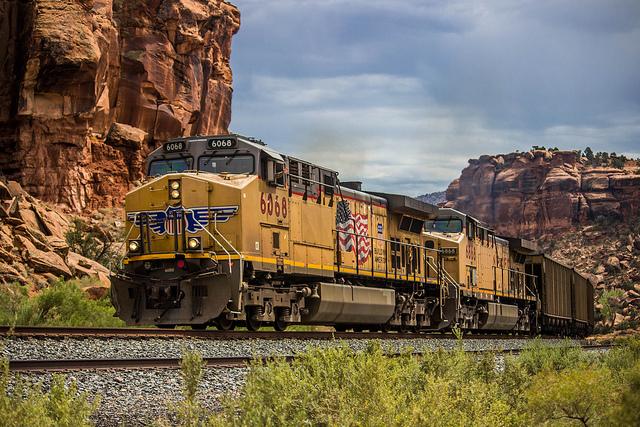Is the sun out?
Quick response, please. Yes. Is this train prepared for climbing terrain?
Be succinct. Yes. Is there a church in the background?
Short answer required. No. What country's flag is on the side of the engine car?
Write a very short answer. Usa. Was this picture taken in the United States of America?
Be succinct. Yes. What railway does this train run along?
Keep it brief. Us. Is the landscape flat?
Keep it brief. No. 